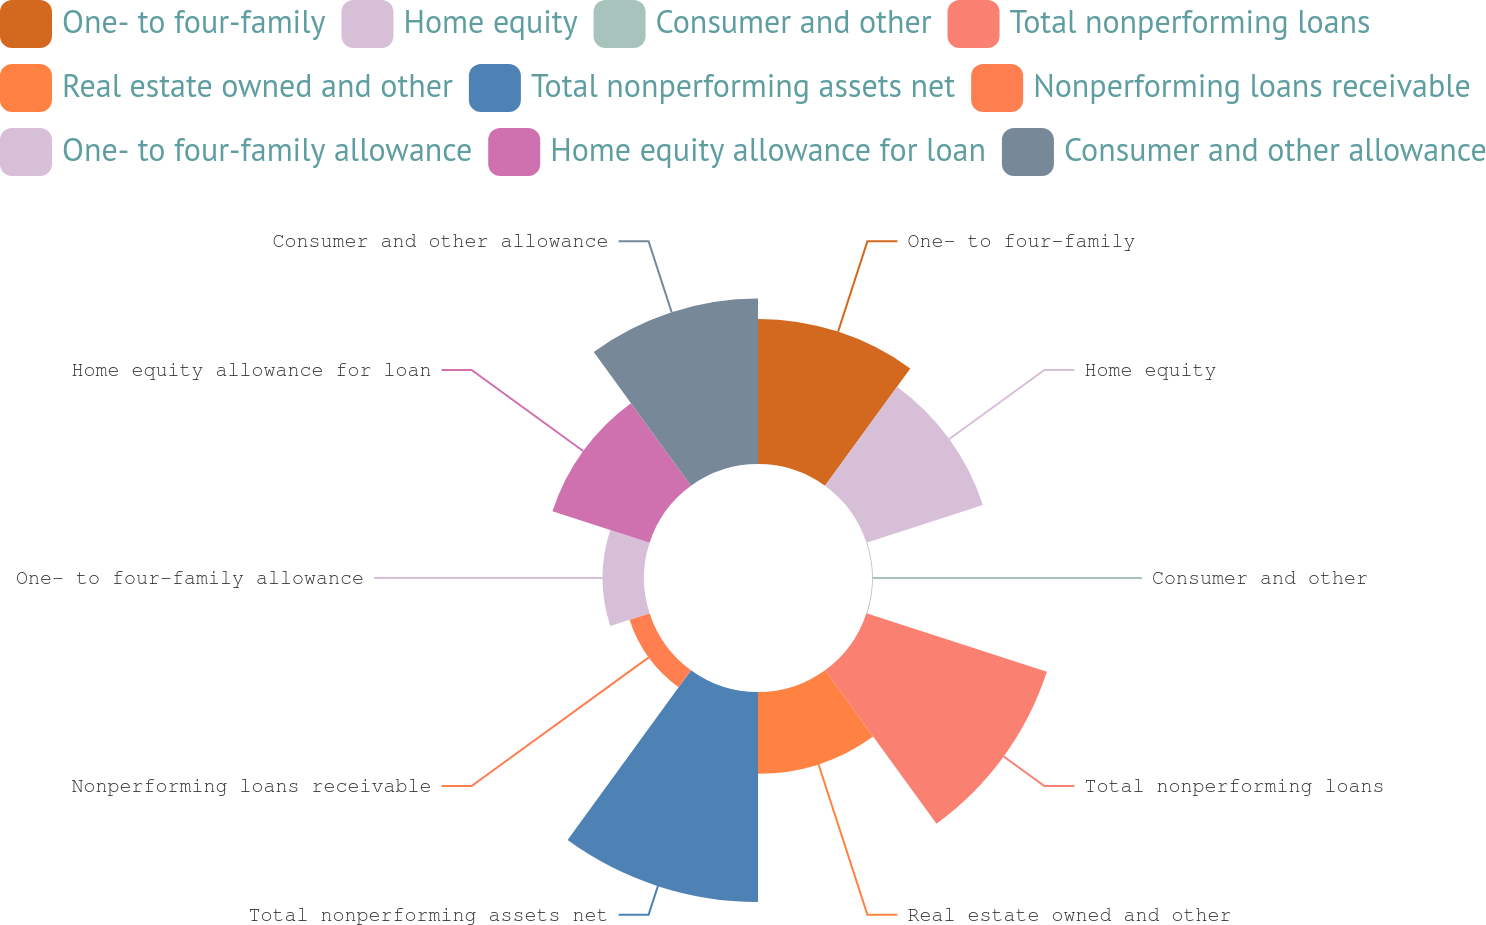<chart> <loc_0><loc_0><loc_500><loc_500><pie_chart><fcel>One- to four-family<fcel>Home equity<fcel>Consumer and other<fcel>Total nonperforming loans<fcel>Real estate owned and other<fcel>Total nonperforming assets net<fcel>Nonperforming loans receivable<fcel>One- to four-family allowance<fcel>Home equity allowance for loan<fcel>Consumer and other allowance<nl><fcel>13.44%<fcel>11.34%<fcel>0.07%<fcel>17.57%<fcel>7.58%<fcel>19.45%<fcel>1.95%<fcel>3.83%<fcel>9.46%<fcel>15.32%<nl></chart> 